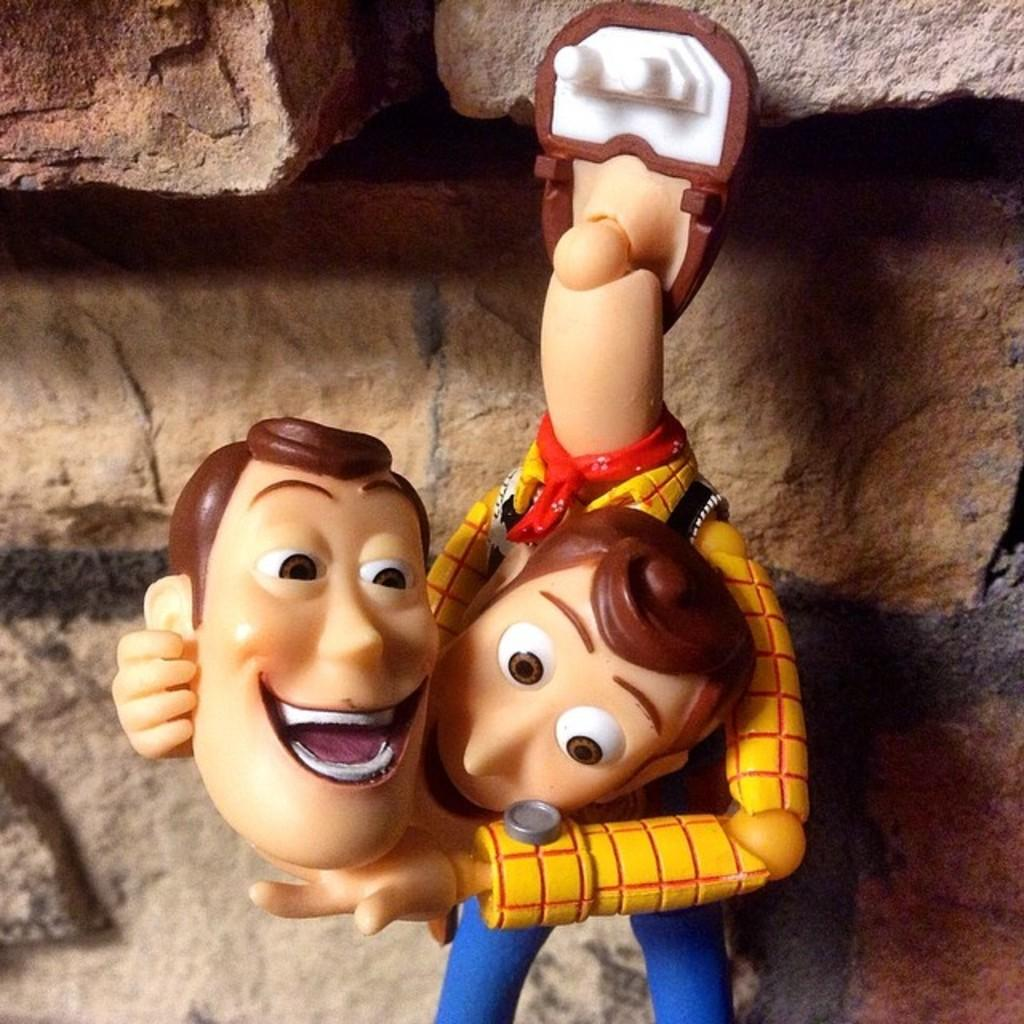What object can be seen in the image? There is a toy in the image. What type of structure is visible in the background of the image? There is a brick wall in the background of the image. What type of ticket is required for the flight shown in the image? There is no flight or ticket present in the image; it only features a toy and a brick wall. 